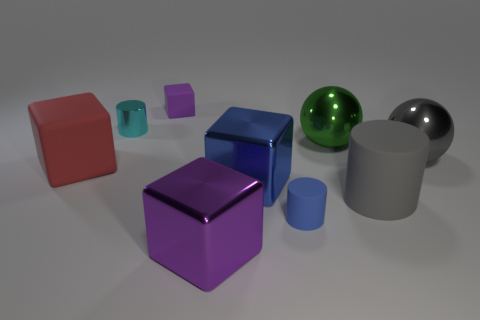What is the material of the small cylinder that is to the right of the tiny matte cube?
Your answer should be very brief. Rubber. Does the small blue matte object have the same shape as the tiny cyan thing behind the large gray matte object?
Provide a short and direct response. Yes. What number of matte cylinders are behind the big metallic thing that is left of the blue thing that is left of the small blue object?
Offer a very short reply. 2. What is the color of the big rubber object that is the same shape as the tiny blue object?
Make the answer very short. Gray. How many blocks are either large objects or large green things?
Make the answer very short. 3. There is a blue rubber object; what shape is it?
Ensure brevity in your answer.  Cylinder. There is a large red block; are there any things to the right of it?
Your answer should be compact. Yes. Does the tiny purple object have the same material as the block that is on the left side of the tiny cyan object?
Provide a succinct answer. Yes. Is the shape of the rubber thing that is on the right side of the blue cylinder the same as  the large green metal thing?
Provide a short and direct response. No. How many small purple things are the same material as the green ball?
Ensure brevity in your answer.  0. 